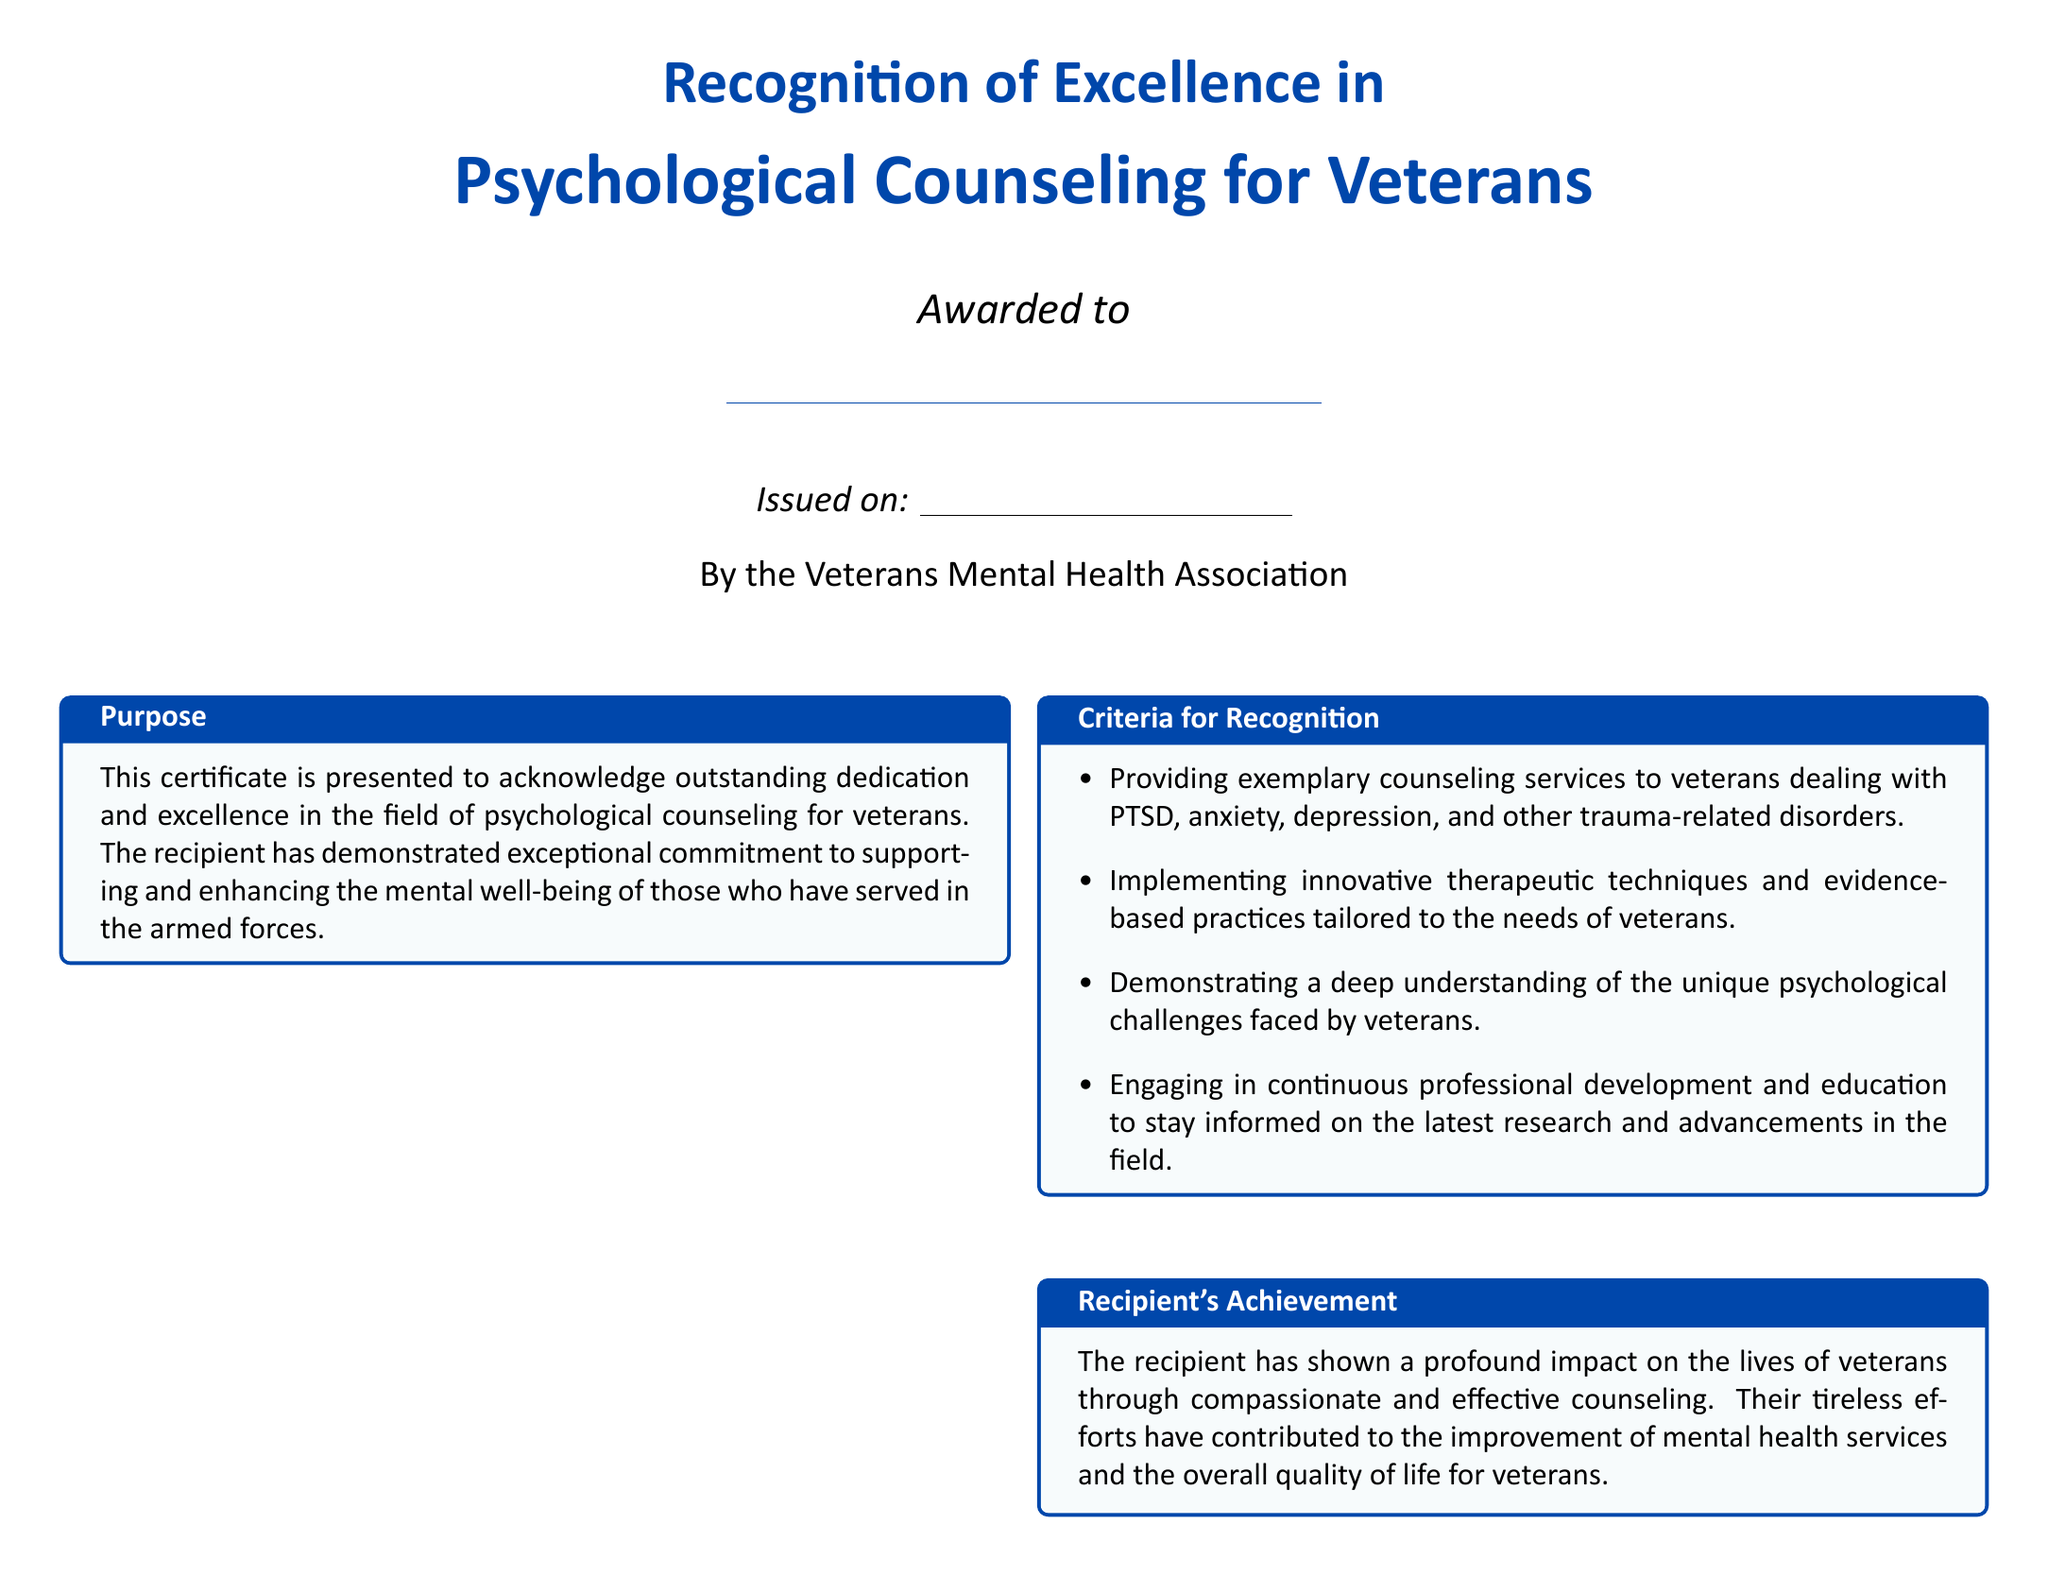What is the title of the certificate? The title of the certificate is prominently displayed at the top of the document as "Recognition of Excellence in Psychological Counseling for Veterans."
Answer: Recognition of Excellence in Psychological Counseling for Veterans Who issued the certificate? The issuer of the certificate is mentioned at the bottom of the document as "By the Veterans Mental Health Association."
Answer: Veterans Mental Health Association What are the criteria for recognition? The document lists specific criteria that together define what excellence in psychological counseling entails; these are outlined in the section titled "Criteria for Recognition."
Answer: Providing exemplary counseling services to veterans dealing with PTSD, anxiety, depression, and other trauma-related disorders Who is the recipient of the certificate? The recipient's name is indicated by a blank line under the title, indicating that it can be filled in with the individual's name.
Answer: \underline{\hspace{8cm}} When was the certificate issued? The date of issuance is located near the bottom of the document, indicated by a blank line that notes "Issued on."
Answer: \underline{\hspace{5cm}} What does the recipient's achievement section describe? The "Recipient's Achievement" section describes the impact the recipient has had on veterans through counseling.
Answer: A profound impact on the lives of veterans through compassionate and effective counseling What did veterans say about the recipient? The testimonials section captures the feedback from veterans regarding their experiences and improvements after counseling.
Answer: Highlighting the positive changes in their mental health and quality of life Who are the signatories of the certificate? The document includes the names and titles of individuals who have signed the certificate at the bottom.
Answer: Dr. Emily Johnson and Michael Anderson 